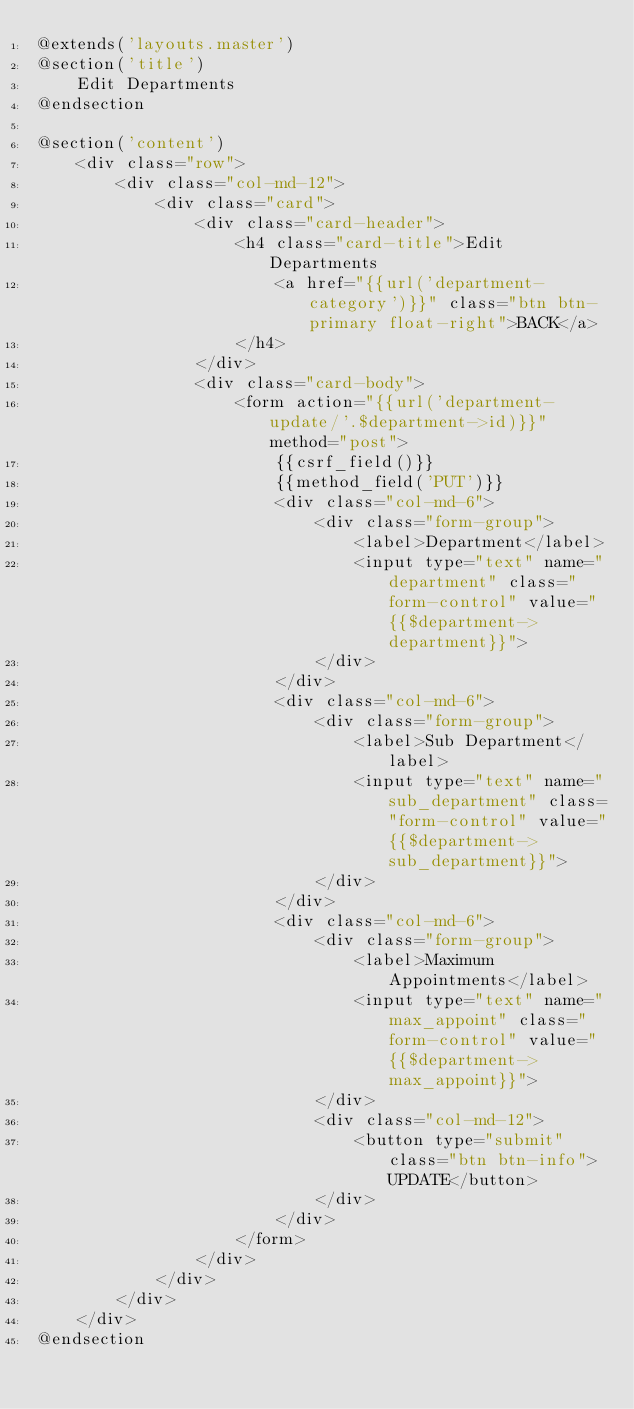<code> <loc_0><loc_0><loc_500><loc_500><_PHP_>@extends('layouts.master')
@section('title')
    Edit Departments
@endsection

@section('content')
    <div class="row">
        <div class="col-md-12">
            <div class="card">
                <div class="card-header">
                    <h4 class="card-title">Edit Departments
                        <a href="{{url('department-category')}}" class="btn btn-primary float-right">BACK</a>
                    </h4>
                </div>
                <div class="card-body">
                    <form action="{{url('department-update/'.$department->id)}}" method="post">
                        {{csrf_field()}}
                        {{method_field('PUT')}}
                        <div class="col-md-6">
                            <div class="form-group">
                                <label>Department</label>
                                <input type="text" name="department" class="form-control" value="{{$department->department}}">
                            </div>
                        </div>
                        <div class="col-md-6">
                            <div class="form-group">
                                <label>Sub Department</label>
                                <input type="text" name="sub_department" class="form-control" value="{{$department->sub_department}}">
                            </div>
                        </div>
                        <div class="col-md-6">
                            <div class="form-group">
                                <label>Maximum Appointments</label>
                                <input type="text" name="max_appoint" class="form-control" value="{{$department->max_appoint}}">
                            </div>
                            <div class="col-md-12">
                                <button type="submit" class="btn btn-info">UPDATE</button>
                            </div>
                        </div>
                    </form>
                </div>
            </div>
        </div>
    </div>
@endsection
</code> 